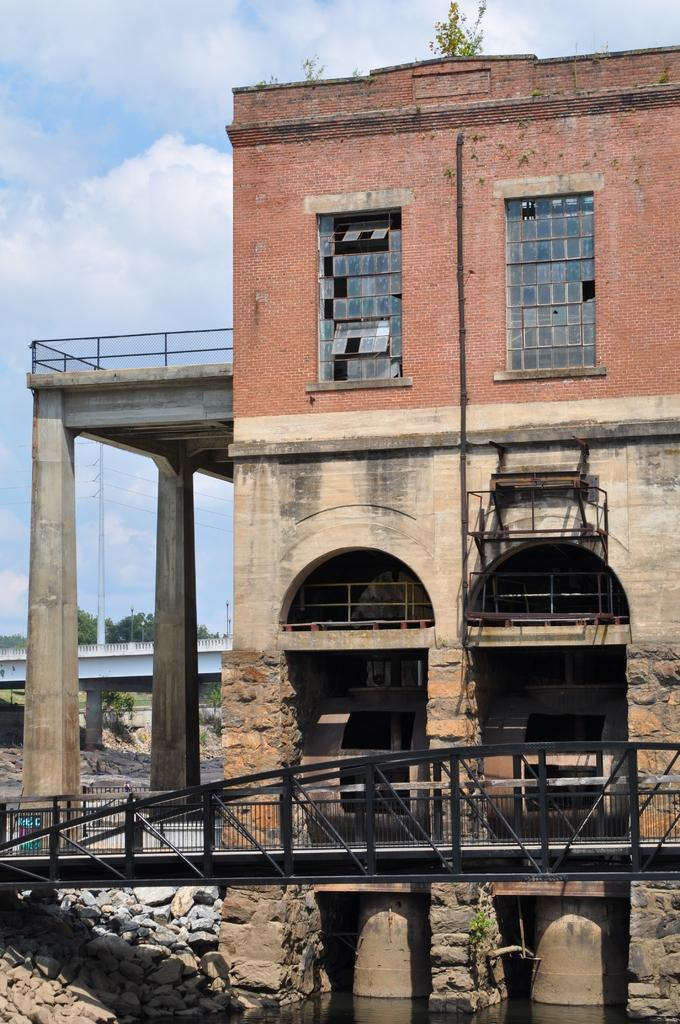What type of structure is in the image? There is a building in the image. What feature of the building is mentioned in the facts? The building has windows. What natural feature is present in the image? There is a bridgewater in the image. What type of terrain is visible in the image? Rocks are present in the image. What part of the natural environment is visible in the image? The sky is visible in the image, and clouds are visible as well. How many goldfish can be seen swimming in the bridgewater in the image? There are no goldfish present in the image; it features a building, rocks, and a bridgewater, but no goldfish. What type of transportation is available for rent near the building in the image? The facts provided do not mention any transportation options, such as bikes, near the building in the image. 